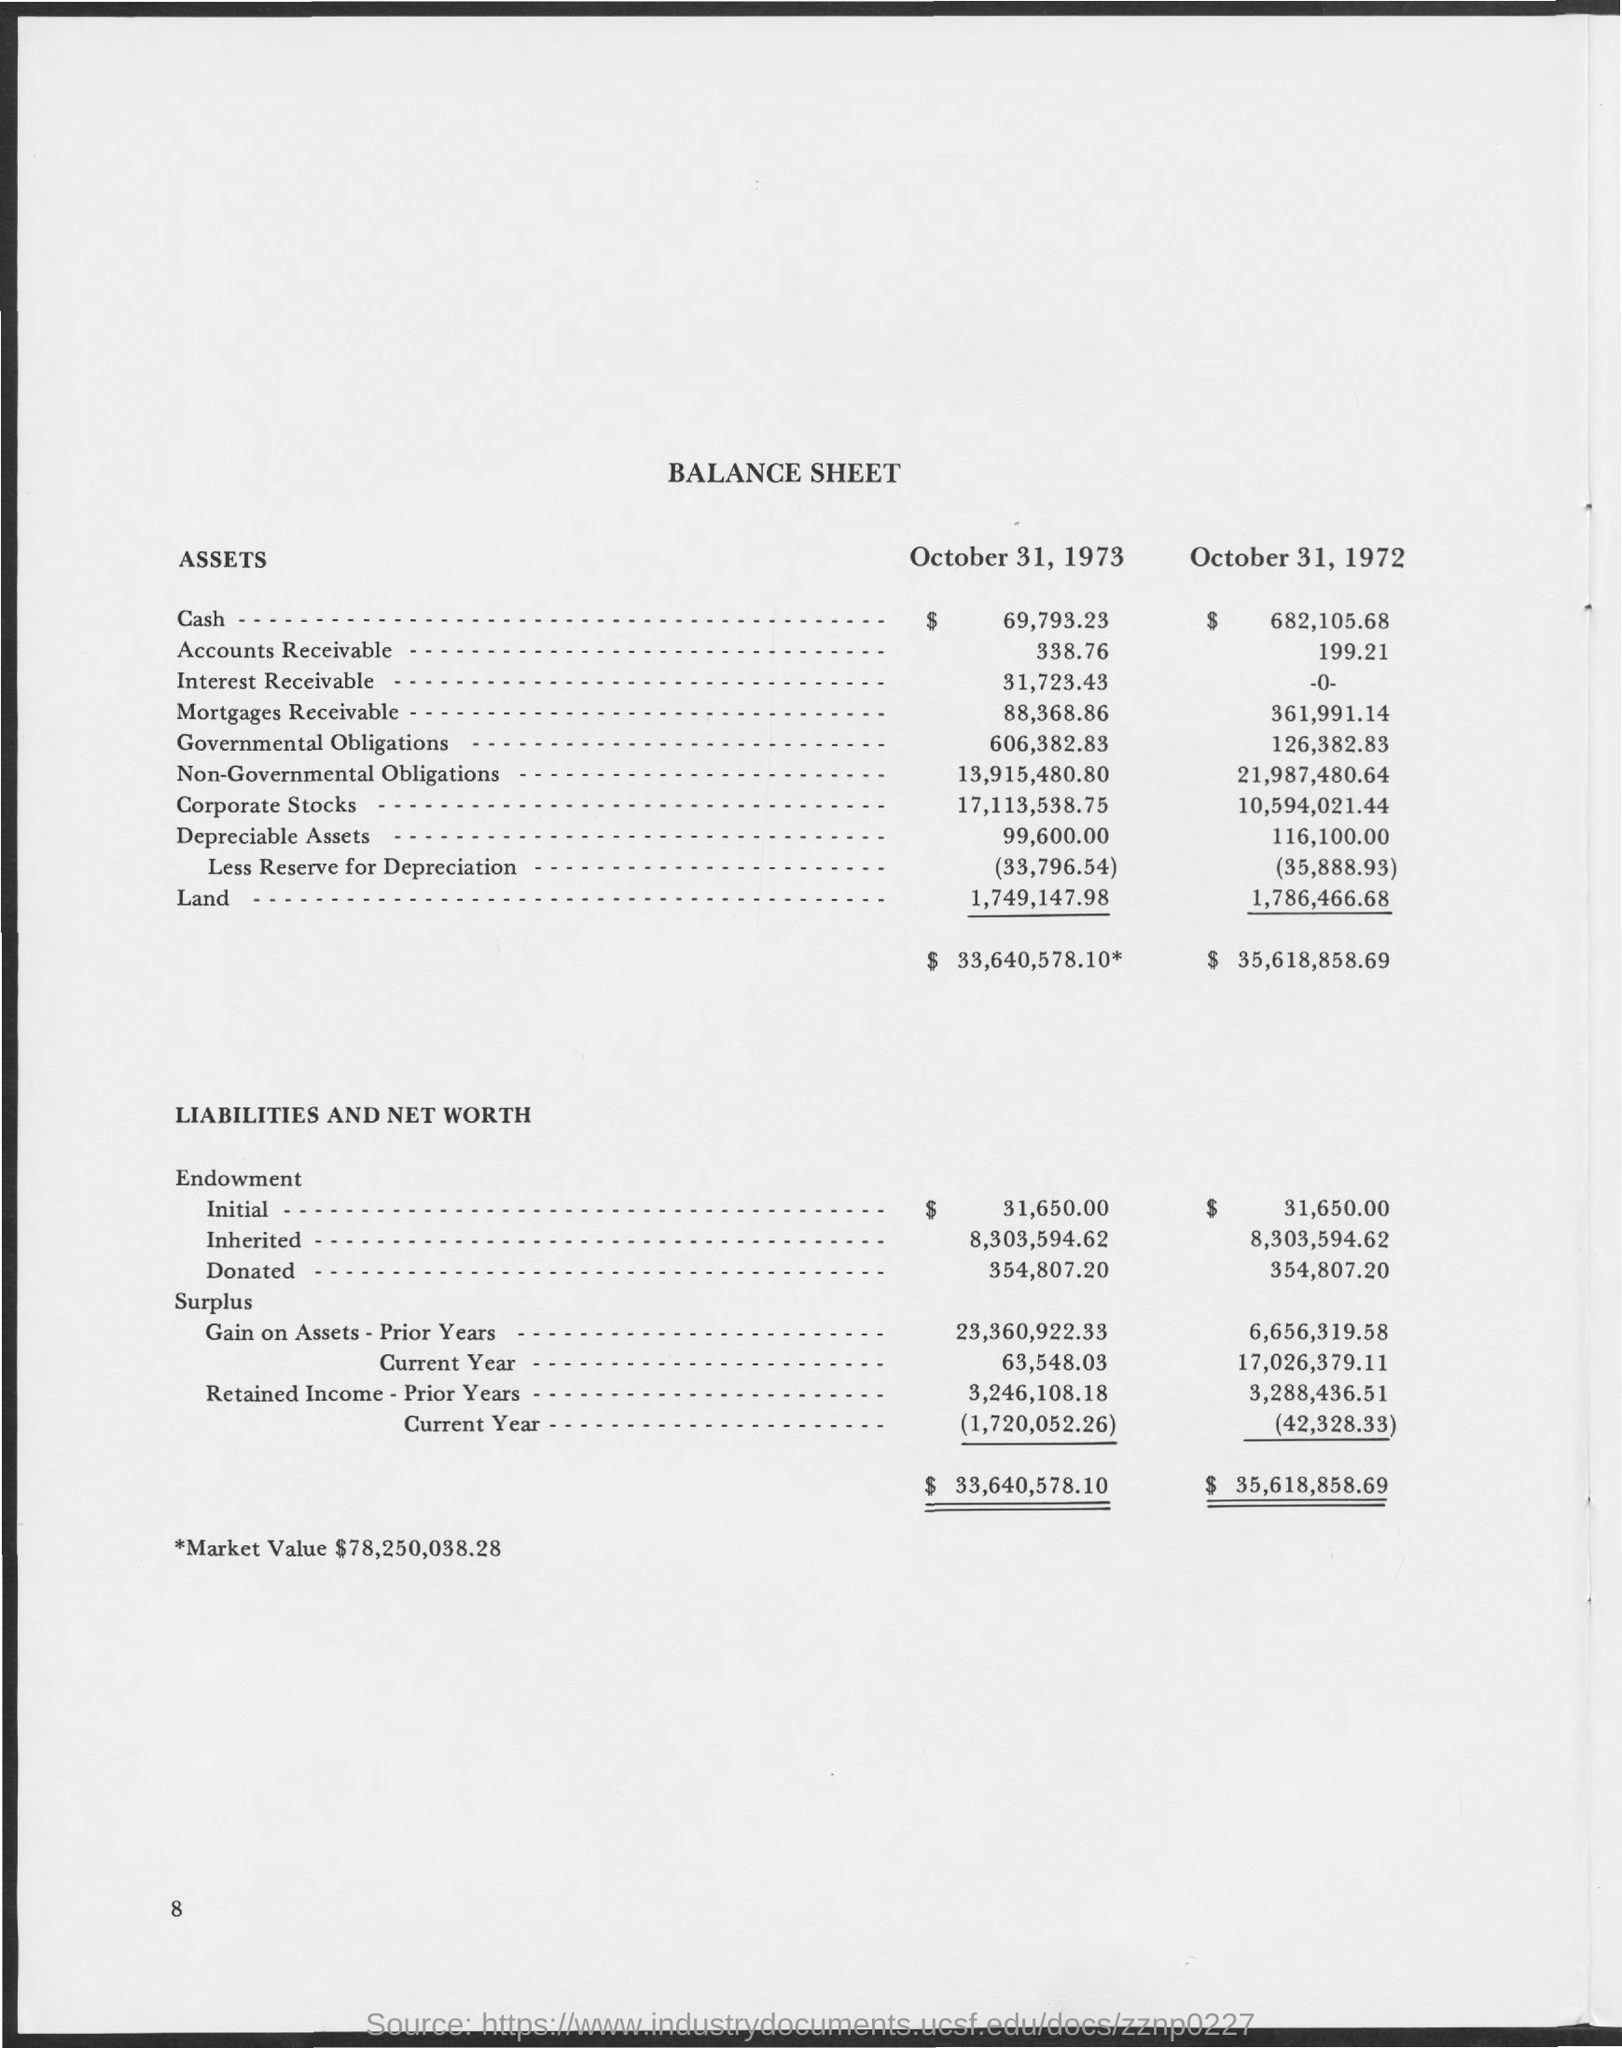Identify some key points in this picture. The market value mentioned in the balance sheet is $78,250,038,281. 